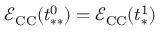<formula> <loc_0><loc_0><loc_500><loc_500>\mathcal { E } _ { C C } ( t _ { * * } ^ { 0 } ) = \mathcal { E } _ { C C } ( t _ { * } ^ { 1 } )</formula> 